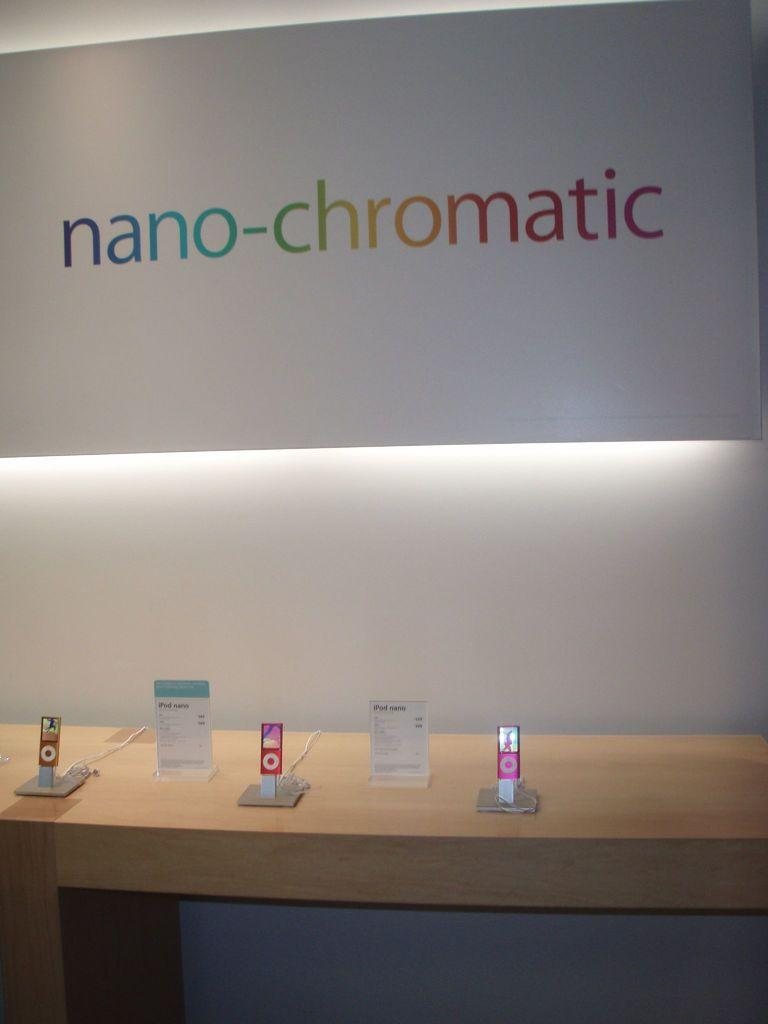What type of product is displayed in the image? There are three AirPods in the image. Where are the AirPods placed in the image? The AirPods are placed on a table. What is the purpose of the display? The purpose of the display is for demonstration. How can the price of the AirPods be identified in the image? There are price badges beside the AirPods. What can be seen in the background of the image? There is a board titled "nano chromatic" in the background of the image. What type of steel is used to make the calculator in the image? There is no calculator present in the image. What kind of toys are displayed on the table with the AirPods? There are no toys displayed on the table with the AirPods; only the AirPods and price badges are present. 